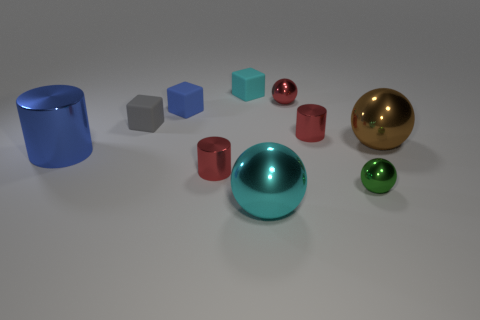There is a tiny red cylinder that is to the left of the cylinder that is on the right side of the small cyan object; what is its material?
Keep it short and to the point. Metal. What is the size of the red metallic cylinder behind the blue metal object?
Offer a terse response. Small. There is a big metal cylinder; does it have the same color as the small thing that is left of the blue matte block?
Make the answer very short. No. Is there a small thing of the same color as the large metal cylinder?
Your answer should be very brief. Yes. Is the tiny red sphere made of the same material as the large ball behind the green object?
Your response must be concise. Yes. How many tiny objects are red metallic balls or yellow shiny blocks?
Ensure brevity in your answer.  1. What material is the thing that is the same color as the large metal cylinder?
Your answer should be compact. Rubber. Are there fewer small blue balls than big brown spheres?
Offer a terse response. Yes. There is a cyan object that is in front of the large blue metallic cylinder; is it the same size as the sphere on the right side of the green shiny thing?
Provide a short and direct response. Yes. What number of blue objects are either large metal cylinders or small things?
Your response must be concise. 2. 